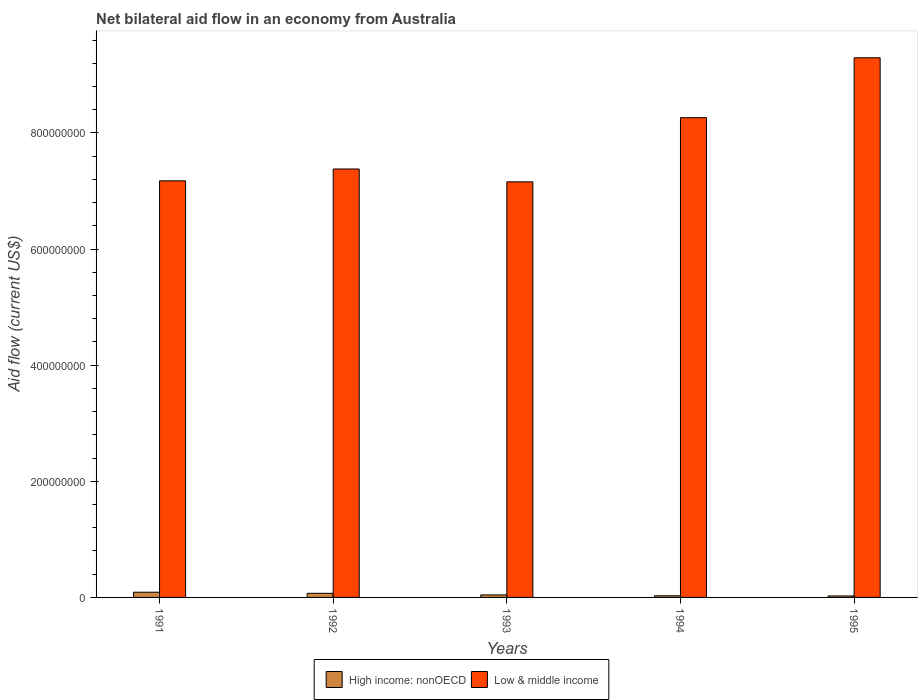How many different coloured bars are there?
Your response must be concise. 2. In how many cases, is the number of bars for a given year not equal to the number of legend labels?
Offer a terse response. 0. What is the net bilateral aid flow in High income: nonOECD in 1993?
Keep it short and to the point. 4.34e+06. Across all years, what is the maximum net bilateral aid flow in Low & middle income?
Offer a terse response. 9.29e+08. Across all years, what is the minimum net bilateral aid flow in High income: nonOECD?
Offer a very short reply. 2.53e+06. In which year was the net bilateral aid flow in Low & middle income maximum?
Your answer should be very brief. 1995. What is the total net bilateral aid flow in High income: nonOECD in the graph?
Keep it short and to the point. 2.57e+07. What is the difference between the net bilateral aid flow in High income: nonOECD in 1993 and that in 1994?
Ensure brevity in your answer.  1.52e+06. What is the difference between the net bilateral aid flow in Low & middle income in 1993 and the net bilateral aid flow in High income: nonOECD in 1994?
Keep it short and to the point. 7.13e+08. What is the average net bilateral aid flow in High income: nonOECD per year?
Offer a very short reply. 5.15e+06. In the year 1993, what is the difference between the net bilateral aid flow in High income: nonOECD and net bilateral aid flow in Low & middle income?
Keep it short and to the point. -7.11e+08. In how many years, is the net bilateral aid flow in High income: nonOECD greater than 440000000 US$?
Offer a very short reply. 0. What is the ratio of the net bilateral aid flow in High income: nonOECD in 1991 to that in 1994?
Ensure brevity in your answer.  3.18. Is the difference between the net bilateral aid flow in High income: nonOECD in 1991 and 1994 greater than the difference between the net bilateral aid flow in Low & middle income in 1991 and 1994?
Keep it short and to the point. Yes. What is the difference between the highest and the second highest net bilateral aid flow in High income: nonOECD?
Your answer should be very brief. 1.90e+06. What is the difference between the highest and the lowest net bilateral aid flow in High income: nonOECD?
Provide a short and direct response. 6.44e+06. Is the sum of the net bilateral aid flow in Low & middle income in 1991 and 1992 greater than the maximum net bilateral aid flow in High income: nonOECD across all years?
Offer a terse response. Yes. What does the 2nd bar from the right in 1995 represents?
Provide a succinct answer. High income: nonOECD. Are all the bars in the graph horizontal?
Your answer should be compact. No. How many years are there in the graph?
Provide a short and direct response. 5. Are the values on the major ticks of Y-axis written in scientific E-notation?
Your response must be concise. No. Does the graph contain any zero values?
Make the answer very short. No. Does the graph contain grids?
Offer a terse response. No. What is the title of the graph?
Keep it short and to the point. Net bilateral aid flow in an economy from Australia. Does "Israel" appear as one of the legend labels in the graph?
Your response must be concise. No. What is the label or title of the Y-axis?
Make the answer very short. Aid flow (current US$). What is the Aid flow (current US$) in High income: nonOECD in 1991?
Keep it short and to the point. 8.97e+06. What is the Aid flow (current US$) of Low & middle income in 1991?
Make the answer very short. 7.18e+08. What is the Aid flow (current US$) in High income: nonOECD in 1992?
Make the answer very short. 7.07e+06. What is the Aid flow (current US$) of Low & middle income in 1992?
Offer a very short reply. 7.38e+08. What is the Aid flow (current US$) in High income: nonOECD in 1993?
Keep it short and to the point. 4.34e+06. What is the Aid flow (current US$) of Low & middle income in 1993?
Make the answer very short. 7.16e+08. What is the Aid flow (current US$) of High income: nonOECD in 1994?
Offer a very short reply. 2.82e+06. What is the Aid flow (current US$) of Low & middle income in 1994?
Offer a terse response. 8.26e+08. What is the Aid flow (current US$) of High income: nonOECD in 1995?
Provide a short and direct response. 2.53e+06. What is the Aid flow (current US$) of Low & middle income in 1995?
Keep it short and to the point. 9.29e+08. Across all years, what is the maximum Aid flow (current US$) of High income: nonOECD?
Your answer should be very brief. 8.97e+06. Across all years, what is the maximum Aid flow (current US$) in Low & middle income?
Make the answer very short. 9.29e+08. Across all years, what is the minimum Aid flow (current US$) of High income: nonOECD?
Keep it short and to the point. 2.53e+06. Across all years, what is the minimum Aid flow (current US$) of Low & middle income?
Make the answer very short. 7.16e+08. What is the total Aid flow (current US$) in High income: nonOECD in the graph?
Your response must be concise. 2.57e+07. What is the total Aid flow (current US$) of Low & middle income in the graph?
Give a very brief answer. 3.93e+09. What is the difference between the Aid flow (current US$) of High income: nonOECD in 1991 and that in 1992?
Offer a terse response. 1.90e+06. What is the difference between the Aid flow (current US$) of Low & middle income in 1991 and that in 1992?
Your answer should be very brief. -2.04e+07. What is the difference between the Aid flow (current US$) of High income: nonOECD in 1991 and that in 1993?
Your answer should be very brief. 4.63e+06. What is the difference between the Aid flow (current US$) in Low & middle income in 1991 and that in 1993?
Your answer should be compact. 1.78e+06. What is the difference between the Aid flow (current US$) in High income: nonOECD in 1991 and that in 1994?
Provide a succinct answer. 6.15e+06. What is the difference between the Aid flow (current US$) in Low & middle income in 1991 and that in 1994?
Your response must be concise. -1.09e+08. What is the difference between the Aid flow (current US$) in High income: nonOECD in 1991 and that in 1995?
Your answer should be compact. 6.44e+06. What is the difference between the Aid flow (current US$) in Low & middle income in 1991 and that in 1995?
Your response must be concise. -2.12e+08. What is the difference between the Aid flow (current US$) in High income: nonOECD in 1992 and that in 1993?
Offer a terse response. 2.73e+06. What is the difference between the Aid flow (current US$) in Low & middle income in 1992 and that in 1993?
Ensure brevity in your answer.  2.21e+07. What is the difference between the Aid flow (current US$) in High income: nonOECD in 1992 and that in 1994?
Your response must be concise. 4.25e+06. What is the difference between the Aid flow (current US$) in Low & middle income in 1992 and that in 1994?
Your answer should be very brief. -8.84e+07. What is the difference between the Aid flow (current US$) in High income: nonOECD in 1992 and that in 1995?
Offer a very short reply. 4.54e+06. What is the difference between the Aid flow (current US$) of Low & middle income in 1992 and that in 1995?
Provide a succinct answer. -1.92e+08. What is the difference between the Aid flow (current US$) in High income: nonOECD in 1993 and that in 1994?
Provide a short and direct response. 1.52e+06. What is the difference between the Aid flow (current US$) of Low & middle income in 1993 and that in 1994?
Keep it short and to the point. -1.11e+08. What is the difference between the Aid flow (current US$) in High income: nonOECD in 1993 and that in 1995?
Your answer should be very brief. 1.81e+06. What is the difference between the Aid flow (current US$) in Low & middle income in 1993 and that in 1995?
Your answer should be compact. -2.14e+08. What is the difference between the Aid flow (current US$) in High income: nonOECD in 1994 and that in 1995?
Give a very brief answer. 2.90e+05. What is the difference between the Aid flow (current US$) of Low & middle income in 1994 and that in 1995?
Your answer should be compact. -1.03e+08. What is the difference between the Aid flow (current US$) of High income: nonOECD in 1991 and the Aid flow (current US$) of Low & middle income in 1992?
Give a very brief answer. -7.29e+08. What is the difference between the Aid flow (current US$) of High income: nonOECD in 1991 and the Aid flow (current US$) of Low & middle income in 1993?
Offer a very short reply. -7.07e+08. What is the difference between the Aid flow (current US$) of High income: nonOECD in 1991 and the Aid flow (current US$) of Low & middle income in 1994?
Ensure brevity in your answer.  -8.17e+08. What is the difference between the Aid flow (current US$) of High income: nonOECD in 1991 and the Aid flow (current US$) of Low & middle income in 1995?
Offer a terse response. -9.20e+08. What is the difference between the Aid flow (current US$) in High income: nonOECD in 1992 and the Aid flow (current US$) in Low & middle income in 1993?
Keep it short and to the point. -7.09e+08. What is the difference between the Aid flow (current US$) of High income: nonOECD in 1992 and the Aid flow (current US$) of Low & middle income in 1994?
Provide a short and direct response. -8.19e+08. What is the difference between the Aid flow (current US$) of High income: nonOECD in 1992 and the Aid flow (current US$) of Low & middle income in 1995?
Provide a succinct answer. -9.22e+08. What is the difference between the Aid flow (current US$) in High income: nonOECD in 1993 and the Aid flow (current US$) in Low & middle income in 1994?
Offer a very short reply. -8.22e+08. What is the difference between the Aid flow (current US$) of High income: nonOECD in 1993 and the Aid flow (current US$) of Low & middle income in 1995?
Your answer should be very brief. -9.25e+08. What is the difference between the Aid flow (current US$) of High income: nonOECD in 1994 and the Aid flow (current US$) of Low & middle income in 1995?
Your response must be concise. -9.27e+08. What is the average Aid flow (current US$) of High income: nonOECD per year?
Your answer should be compact. 5.15e+06. What is the average Aid flow (current US$) in Low & middle income per year?
Offer a terse response. 7.85e+08. In the year 1991, what is the difference between the Aid flow (current US$) of High income: nonOECD and Aid flow (current US$) of Low & middle income?
Offer a terse response. -7.09e+08. In the year 1992, what is the difference between the Aid flow (current US$) in High income: nonOECD and Aid flow (current US$) in Low & middle income?
Your answer should be very brief. -7.31e+08. In the year 1993, what is the difference between the Aid flow (current US$) of High income: nonOECD and Aid flow (current US$) of Low & middle income?
Provide a short and direct response. -7.11e+08. In the year 1994, what is the difference between the Aid flow (current US$) of High income: nonOECD and Aid flow (current US$) of Low & middle income?
Make the answer very short. -8.23e+08. In the year 1995, what is the difference between the Aid flow (current US$) of High income: nonOECD and Aid flow (current US$) of Low & middle income?
Provide a short and direct response. -9.27e+08. What is the ratio of the Aid flow (current US$) in High income: nonOECD in 1991 to that in 1992?
Provide a succinct answer. 1.27. What is the ratio of the Aid flow (current US$) in Low & middle income in 1991 to that in 1992?
Your answer should be compact. 0.97. What is the ratio of the Aid flow (current US$) in High income: nonOECD in 1991 to that in 1993?
Keep it short and to the point. 2.07. What is the ratio of the Aid flow (current US$) in High income: nonOECD in 1991 to that in 1994?
Provide a short and direct response. 3.18. What is the ratio of the Aid flow (current US$) of Low & middle income in 1991 to that in 1994?
Offer a terse response. 0.87. What is the ratio of the Aid flow (current US$) of High income: nonOECD in 1991 to that in 1995?
Offer a terse response. 3.55. What is the ratio of the Aid flow (current US$) of Low & middle income in 1991 to that in 1995?
Give a very brief answer. 0.77. What is the ratio of the Aid flow (current US$) in High income: nonOECD in 1992 to that in 1993?
Your response must be concise. 1.63. What is the ratio of the Aid flow (current US$) in Low & middle income in 1992 to that in 1993?
Offer a terse response. 1.03. What is the ratio of the Aid flow (current US$) of High income: nonOECD in 1992 to that in 1994?
Make the answer very short. 2.51. What is the ratio of the Aid flow (current US$) of Low & middle income in 1992 to that in 1994?
Your answer should be very brief. 0.89. What is the ratio of the Aid flow (current US$) in High income: nonOECD in 1992 to that in 1995?
Offer a very short reply. 2.79. What is the ratio of the Aid flow (current US$) of Low & middle income in 1992 to that in 1995?
Give a very brief answer. 0.79. What is the ratio of the Aid flow (current US$) of High income: nonOECD in 1993 to that in 1994?
Provide a succinct answer. 1.54. What is the ratio of the Aid flow (current US$) of Low & middle income in 1993 to that in 1994?
Your response must be concise. 0.87. What is the ratio of the Aid flow (current US$) in High income: nonOECD in 1993 to that in 1995?
Offer a terse response. 1.72. What is the ratio of the Aid flow (current US$) in Low & middle income in 1993 to that in 1995?
Give a very brief answer. 0.77. What is the ratio of the Aid flow (current US$) of High income: nonOECD in 1994 to that in 1995?
Your response must be concise. 1.11. What is the ratio of the Aid flow (current US$) in Low & middle income in 1994 to that in 1995?
Your response must be concise. 0.89. What is the difference between the highest and the second highest Aid flow (current US$) of High income: nonOECD?
Provide a short and direct response. 1.90e+06. What is the difference between the highest and the second highest Aid flow (current US$) in Low & middle income?
Offer a very short reply. 1.03e+08. What is the difference between the highest and the lowest Aid flow (current US$) of High income: nonOECD?
Offer a very short reply. 6.44e+06. What is the difference between the highest and the lowest Aid flow (current US$) in Low & middle income?
Give a very brief answer. 2.14e+08. 